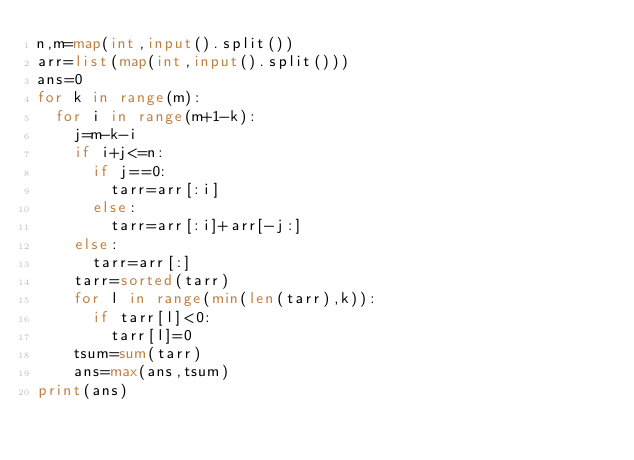<code> <loc_0><loc_0><loc_500><loc_500><_Python_>n,m=map(int,input().split())
arr=list(map(int,input().split()))
ans=0
for k in range(m):
  for i in range(m+1-k):
    j=m-k-i
    if i+j<=n:
      if j==0:
        tarr=arr[:i]
      else:
        tarr=arr[:i]+arr[-j:]
    else:
      tarr=arr[:]
    tarr=sorted(tarr)
    for l in range(min(len(tarr),k)):
      if tarr[l]<0:
        tarr[l]=0
    tsum=sum(tarr)
    ans=max(ans,tsum)
print(ans)</code> 